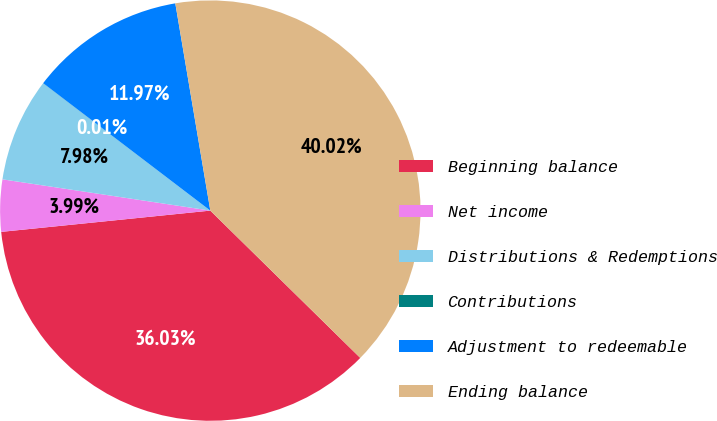Convert chart to OTSL. <chart><loc_0><loc_0><loc_500><loc_500><pie_chart><fcel>Beginning balance<fcel>Net income<fcel>Distributions & Redemptions<fcel>Contributions<fcel>Adjustment to redeemable<fcel>Ending balance<nl><fcel>36.03%<fcel>3.99%<fcel>7.98%<fcel>0.01%<fcel>11.97%<fcel>40.02%<nl></chart> 